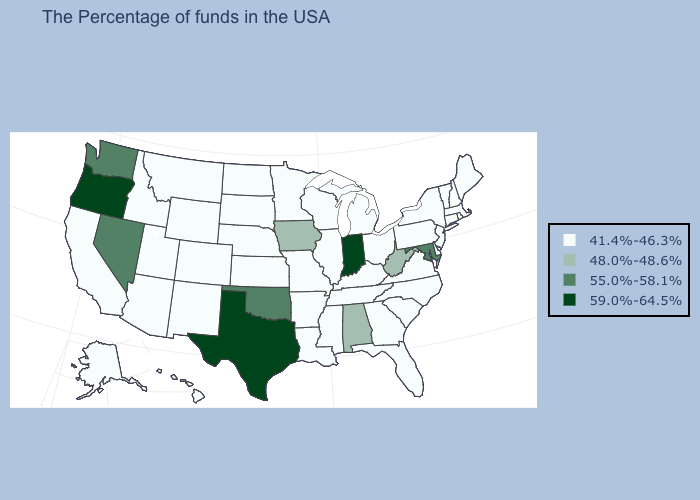Is the legend a continuous bar?
Concise answer only. No. What is the value of South Dakota?
Keep it brief. 41.4%-46.3%. How many symbols are there in the legend?
Give a very brief answer. 4. What is the value of Hawaii?
Write a very short answer. 41.4%-46.3%. Name the states that have a value in the range 55.0%-58.1%?
Give a very brief answer. Maryland, Oklahoma, Nevada, Washington. Does Indiana have the highest value in the USA?
Short answer required. Yes. Which states have the highest value in the USA?
Concise answer only. Indiana, Texas, Oregon. What is the highest value in the USA?
Keep it brief. 59.0%-64.5%. Does Washington have the same value as Nevada?
Write a very short answer. Yes. Does the map have missing data?
Be succinct. No. Among the states that border Utah , which have the lowest value?
Quick response, please. Wyoming, Colorado, New Mexico, Arizona, Idaho. Among the states that border West Virginia , does Virginia have the lowest value?
Quick response, please. Yes. What is the highest value in the South ?
Answer briefly. 59.0%-64.5%. What is the value of Mississippi?
Answer briefly. 41.4%-46.3%. What is the highest value in states that border New Hampshire?
Short answer required. 41.4%-46.3%. 